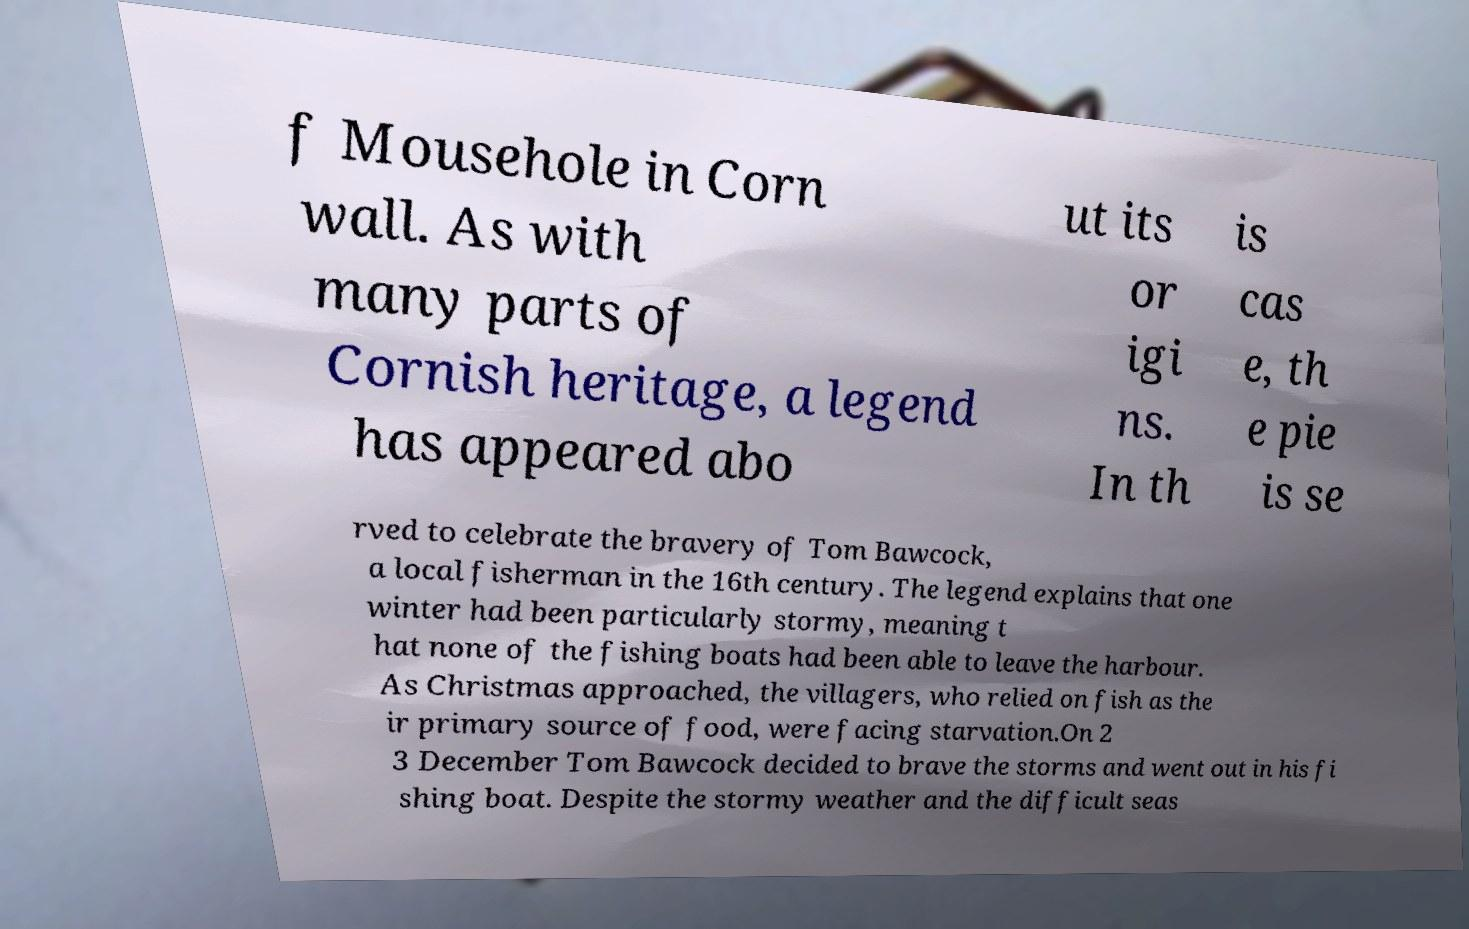Can you accurately transcribe the text from the provided image for me? f Mousehole in Corn wall. As with many parts of Cornish heritage, a legend has appeared abo ut its or igi ns. In th is cas e, th e pie is se rved to celebrate the bravery of Tom Bawcock, a local fisherman in the 16th century. The legend explains that one winter had been particularly stormy, meaning t hat none of the fishing boats had been able to leave the harbour. As Christmas approached, the villagers, who relied on fish as the ir primary source of food, were facing starvation.On 2 3 December Tom Bawcock decided to brave the storms and went out in his fi shing boat. Despite the stormy weather and the difficult seas 